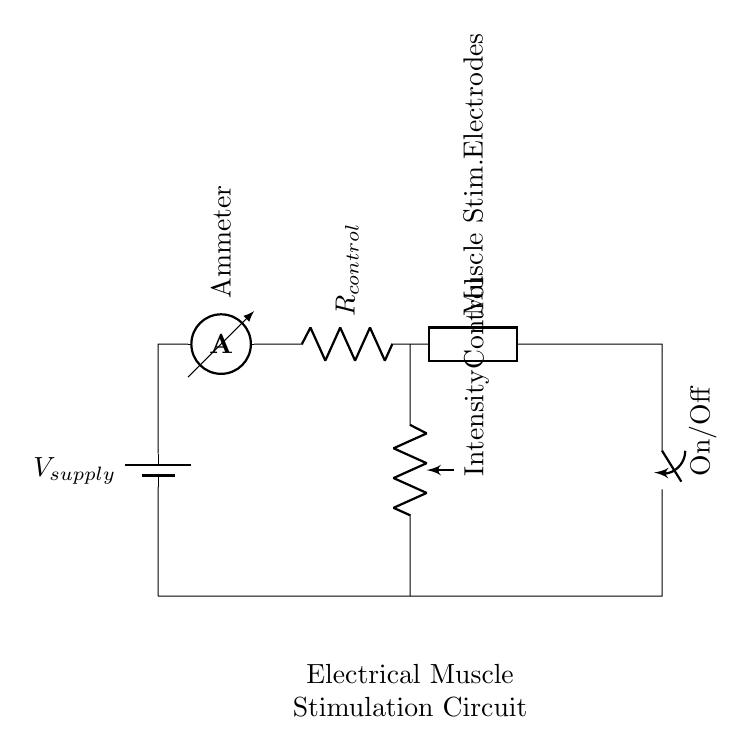What is the main power source in this circuit? The main power source is represented by the battery symbol, labeled as V_supply. This indicates it provides the necessary voltage for the circuit to operate.
Answer: V_supply What is the purpose of the ammeter in this circuit? The ammeter measures the current flowing through the circuit, allowing the user to monitor the intensity of electrical stimulation by displaying the current value.
Answer: Ammeter Which component allows for adjusting the stimulation intensity? The intensity control is provided by the potentiometer, which can be adjusted to change the resistance and thereby the current flowing through the circuit.
Answer: Potentiometer What happens to the circuit when the switch is turned off? When the switch is in the off position, it creates an open circuit, meaning no current will flow and the muscle stimulation will stop as a result.
Answer: Open circuit Explain why the muscle stimulation electrodes are placed in series with the resistor and potentiometer. The muscle stimulation electrodes need to be in series with the resistor and potentiometer to ensure that all the current passes through them, which directly affects the level of stimulation delivered to the muscles, thus allowing for effective control of its intensity.
Answer: To control current flow How does the potentiometer affect the current flow in this circuit? The potentiometer acts as a variable resistor; adjusting it changes the resistance value, which alters the current flow according to Ohm's law, directly influencing the strength of the muscle stimulation as perceived by the user.
Answer: Changes resistance 